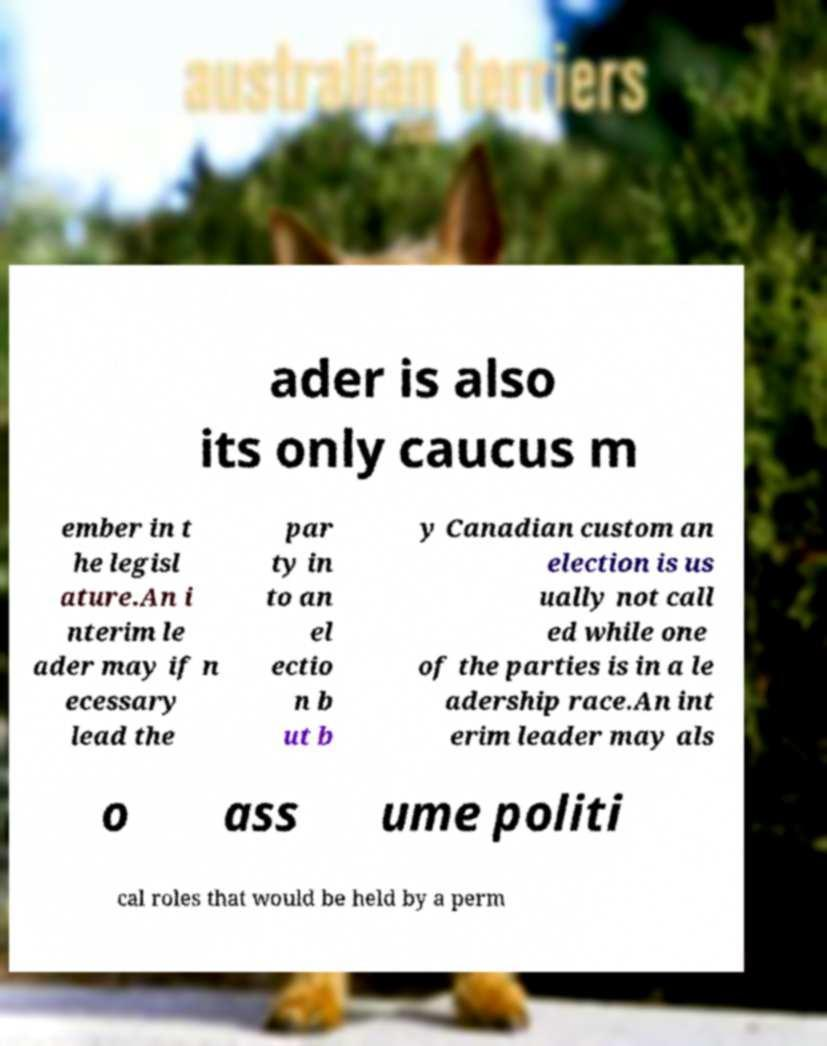What messages or text are displayed in this image? I need them in a readable, typed format. ader is also its only caucus m ember in t he legisl ature.An i nterim le ader may if n ecessary lead the par ty in to an el ectio n b ut b y Canadian custom an election is us ually not call ed while one of the parties is in a le adership race.An int erim leader may als o ass ume politi cal roles that would be held by a perm 